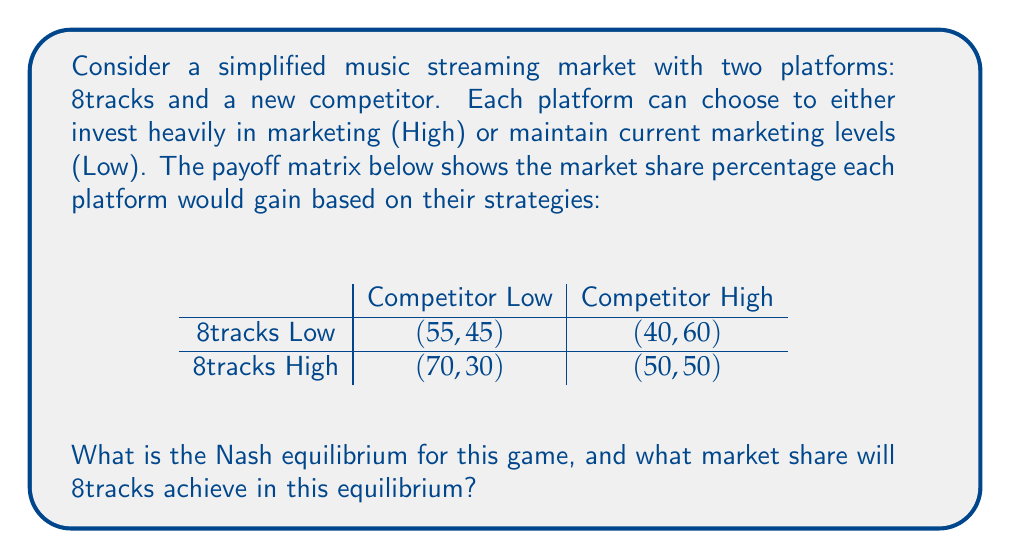Give your solution to this math problem. To find the Nash equilibrium, we need to analyze each player's best response to the other player's strategy:

1. If the competitor chooses Low:
   - 8tracks' best response is High (70% > 55%)

2. If the competitor chooses High:
   - 8tracks' best response is High (50% > 40%)

3. If 8tracks chooses Low:
   - Competitor's best response is High (60% > 45%)

4. If 8tracks chooses High:
   - Competitor's best response is High (50% > 30%)

We can see that regardless of what the competitor does, 8tracks' best strategy is always High. Similarly, the competitor's best strategy is always High, regardless of 8tracks' choice.

Therefore, the Nash equilibrium is (8tracks High, Competitor High). In this equilibrium, both platforms will invest heavily in marketing.

To determine 8tracks' market share in this equilibrium, we look at the payoff for (8tracks High, Competitor High), which is (50, 50).
Answer: The Nash equilibrium is (8tracks High, Competitor High), and 8tracks will achieve a 50% market share in this equilibrium. 